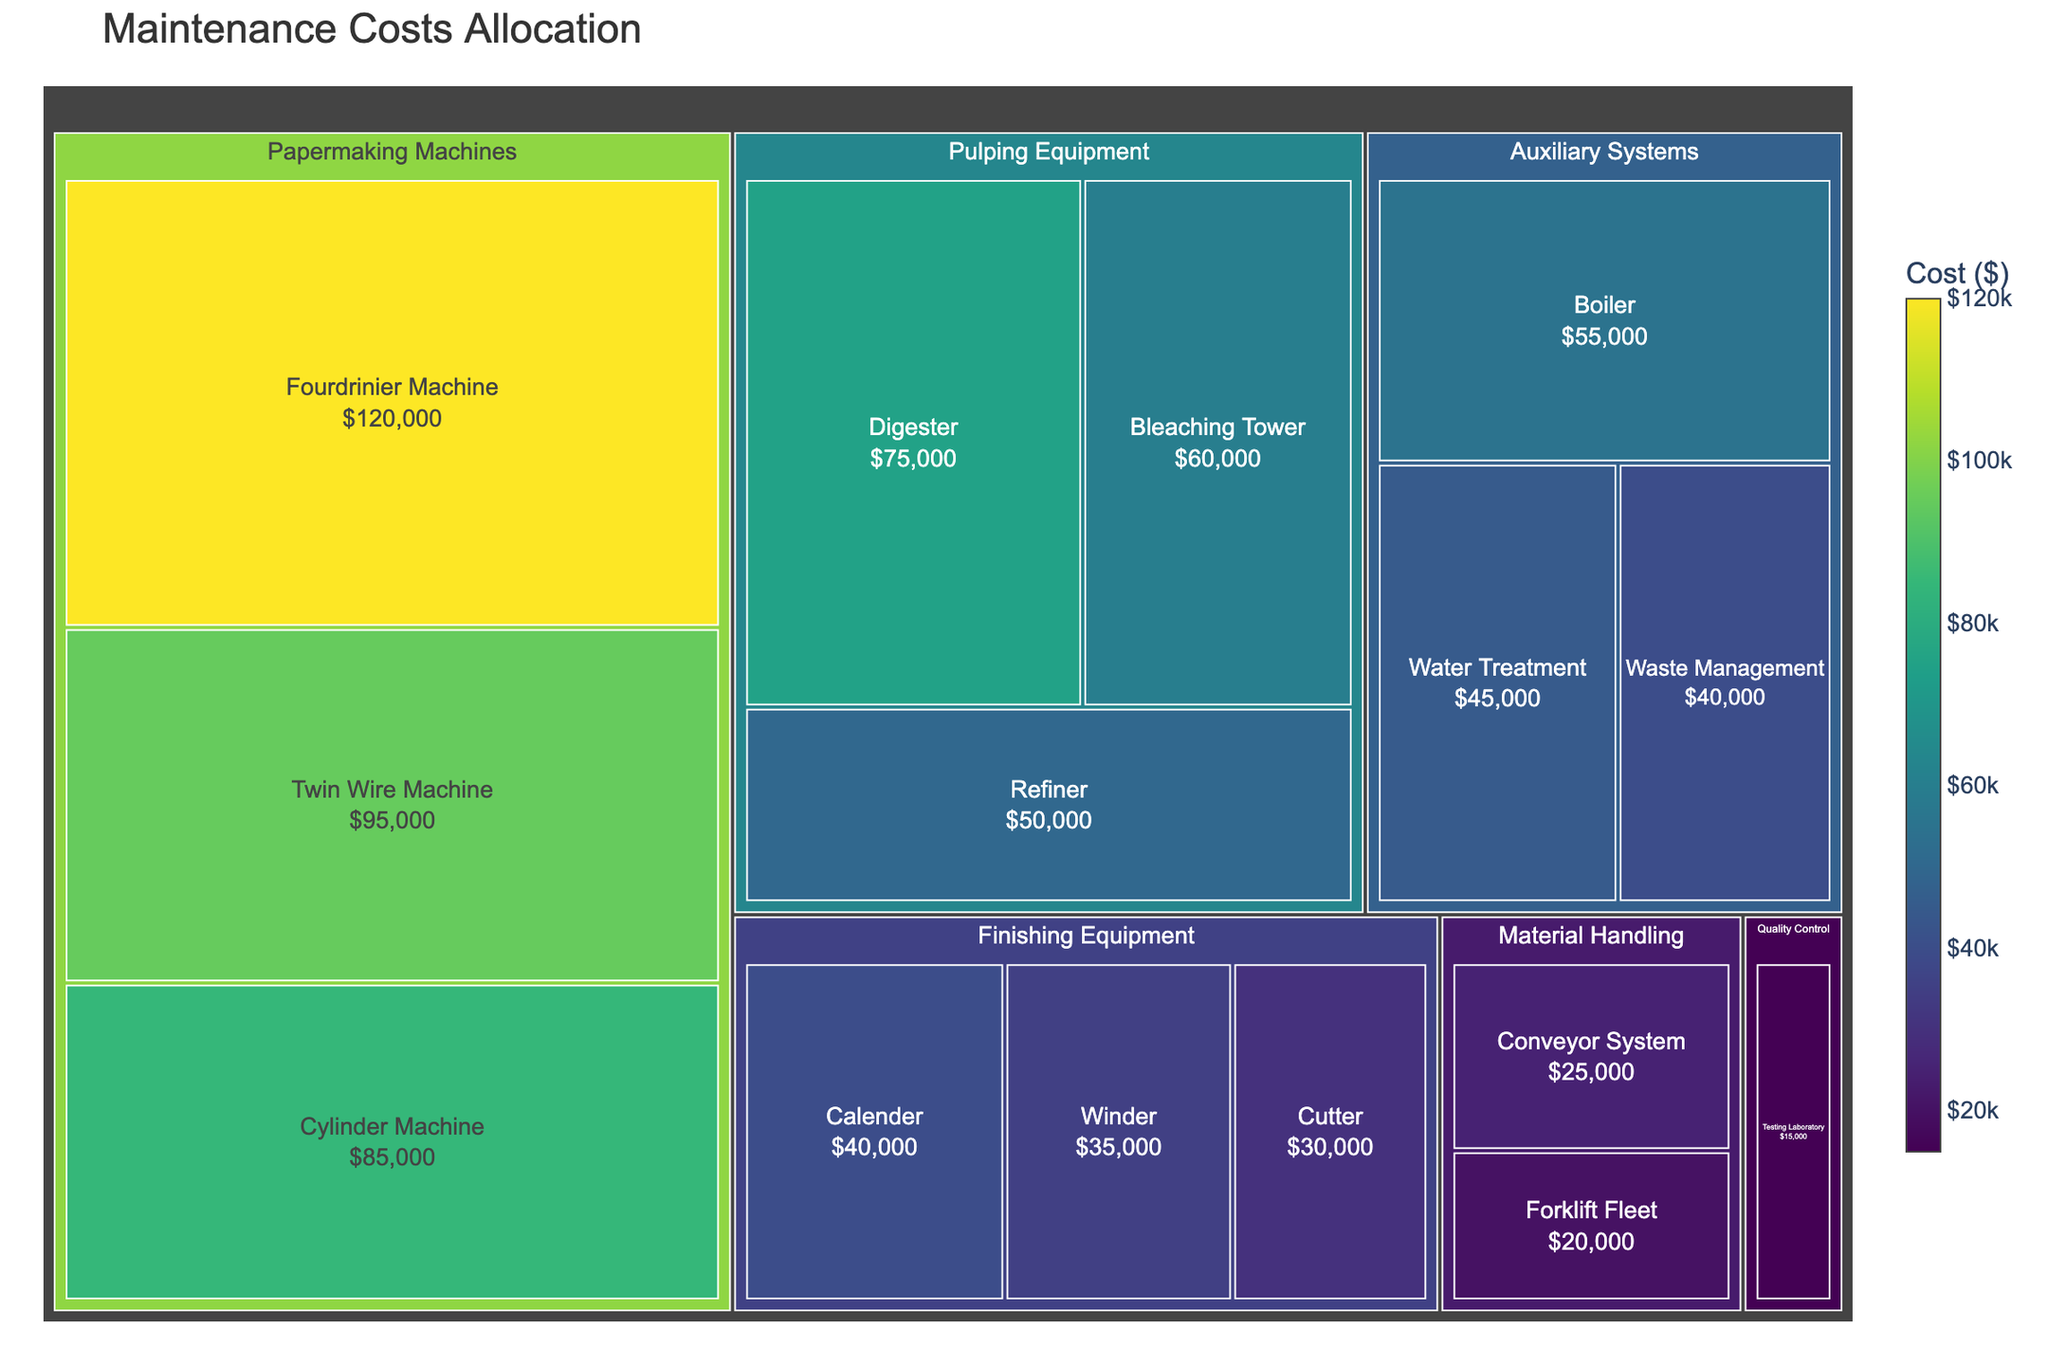what is the cost of maintaining the Fourdrinier Machine The Fourdrinier Machine is under the 'Papermaking Machines' category. The treemap shows a cost of $120,000 for maintaining the Fourdrinier Machine.
Answer: $120,000 which category has the highest maintenance cost Looking at the treemap, the 'Papermaking Machines' category has the highest costs, with multiple subcategories summing up to $300,000 collectively (Fourdrinier Machine: $120,000, Cylinder Machine: $85,000, Twin Wire Machine: $95,000).
Answer: Papermaking Machines what is the maintenance cost difference between the Boiler and the Cutter The Boiler is within the 'Auxiliary Systems' category and has a maintenance cost of $55,000. The Cutter under 'Finishing Equipment' has a maintenance cost of $30,000. The difference between these costs is $55,000 - $30,000 = $25,000.
Answer: $25,000 which subcategory in Papermaking Machines has the lowest maintenance cost Within the 'Papermaking Machines' category, the Twin Wire Machine has a cost of $95,000, Fourdrinier Machine has $120,000, and Cylinder Machine has the lowest at $85,000.
Answer: Cylinder Machine what is the average maintenance cost per subcategory in Auxiliary Systems Auxiliary Systems contain Boiler ($55,000), Water Treatment ($45,000), and Waste Management ($40,000). Their total cost is $55,000 + $45,000 + $40,000 = $140,000, across 3 subcategories, so the average is $140,000 / 3 = $46,667.
Answer: $46,667 how is the cost distributed among Finishing Equipment subcategories Finishing Equipment includes Calender ($40,000), Winder ($35,000), and Cutter ($30,000). A comparison shows gradual decrements: Calender (highest), Winder, and Cutter (lowest).
Answer: Calender > Winder > Cutter 